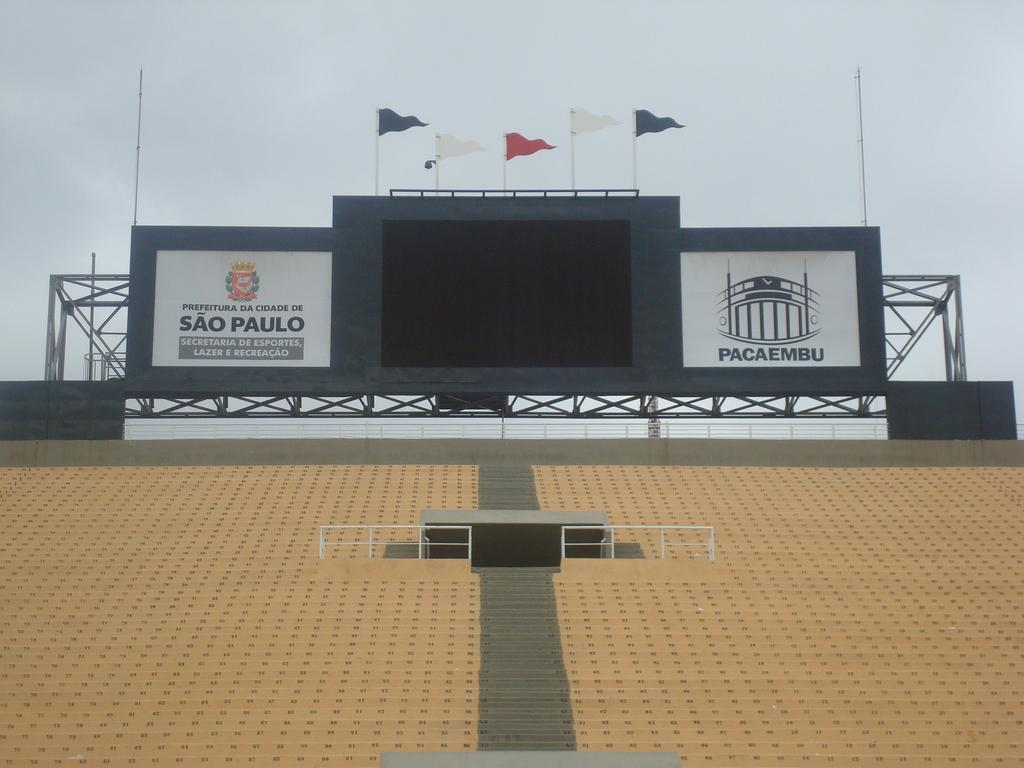<image>
Present a compact description of the photo's key features. A blank scoreboard at the top of bleachers with a Sao Paulo sign to the left. 